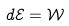<formula> <loc_0><loc_0><loc_500><loc_500>d \mathcal { E } = \mathcal { W }</formula> 